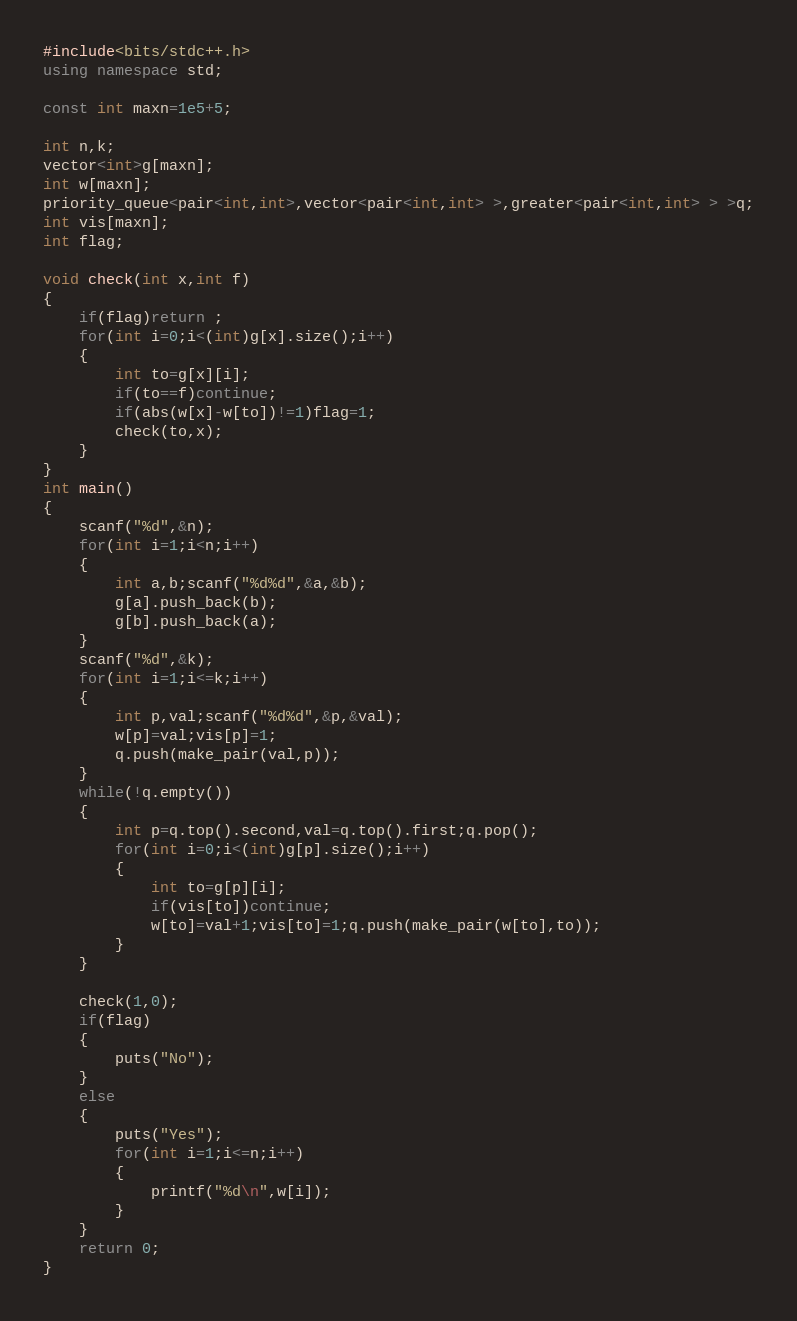Convert code to text. <code><loc_0><loc_0><loc_500><loc_500><_C++_>#include<bits/stdc++.h>
using namespace std;

const int maxn=1e5+5;

int n,k;
vector<int>g[maxn];
int w[maxn];
priority_queue<pair<int,int>,vector<pair<int,int> >,greater<pair<int,int> > >q;
int vis[maxn];
int flag;

void check(int x,int f)
{
	if(flag)return ;
	for(int i=0;i<(int)g[x].size();i++)
	{
		int to=g[x][i];
		if(to==f)continue;
		if(abs(w[x]-w[to])!=1)flag=1;
		check(to,x);
	}
}
int main()
{
	scanf("%d",&n);
	for(int i=1;i<n;i++)
	{
		int a,b;scanf("%d%d",&a,&b);
		g[a].push_back(b);
		g[b].push_back(a);
	}
	scanf("%d",&k);
	for(int i=1;i<=k;i++)
	{
		int p,val;scanf("%d%d",&p,&val);
		w[p]=val;vis[p]=1;
		q.push(make_pair(val,p));
	}
	while(!q.empty())
	{
		int p=q.top().second,val=q.top().first;q.pop();
		for(int i=0;i<(int)g[p].size();i++)
		{
			int to=g[p][i];
			if(vis[to])continue;
			w[to]=val+1;vis[to]=1;q.push(make_pair(w[to],to));
		}
	}
	
	check(1,0);
	if(flag)
	{
		puts("No");
	}
	else
	{
		puts("Yes");
		for(int i=1;i<=n;i++)
		{
			printf("%d\n",w[i]);
		}
	}
	return 0;
}</code> 